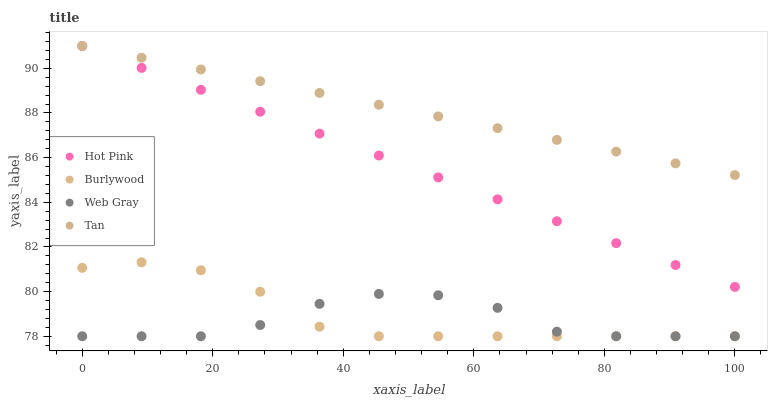Does Web Gray have the minimum area under the curve?
Answer yes or no. Yes. Does Tan have the maximum area under the curve?
Answer yes or no. Yes. Does Hot Pink have the minimum area under the curve?
Answer yes or no. No. Does Hot Pink have the maximum area under the curve?
Answer yes or no. No. Is Tan the smoothest?
Answer yes or no. Yes. Is Web Gray the roughest?
Answer yes or no. Yes. Is Hot Pink the smoothest?
Answer yes or no. No. Is Hot Pink the roughest?
Answer yes or no. No. Does Burlywood have the lowest value?
Answer yes or no. Yes. Does Hot Pink have the lowest value?
Answer yes or no. No. Does Hot Pink have the highest value?
Answer yes or no. Yes. Does Web Gray have the highest value?
Answer yes or no. No. Is Web Gray less than Tan?
Answer yes or no. Yes. Is Hot Pink greater than Web Gray?
Answer yes or no. Yes. Does Hot Pink intersect Tan?
Answer yes or no. Yes. Is Hot Pink less than Tan?
Answer yes or no. No. Is Hot Pink greater than Tan?
Answer yes or no. No. Does Web Gray intersect Tan?
Answer yes or no. No. 